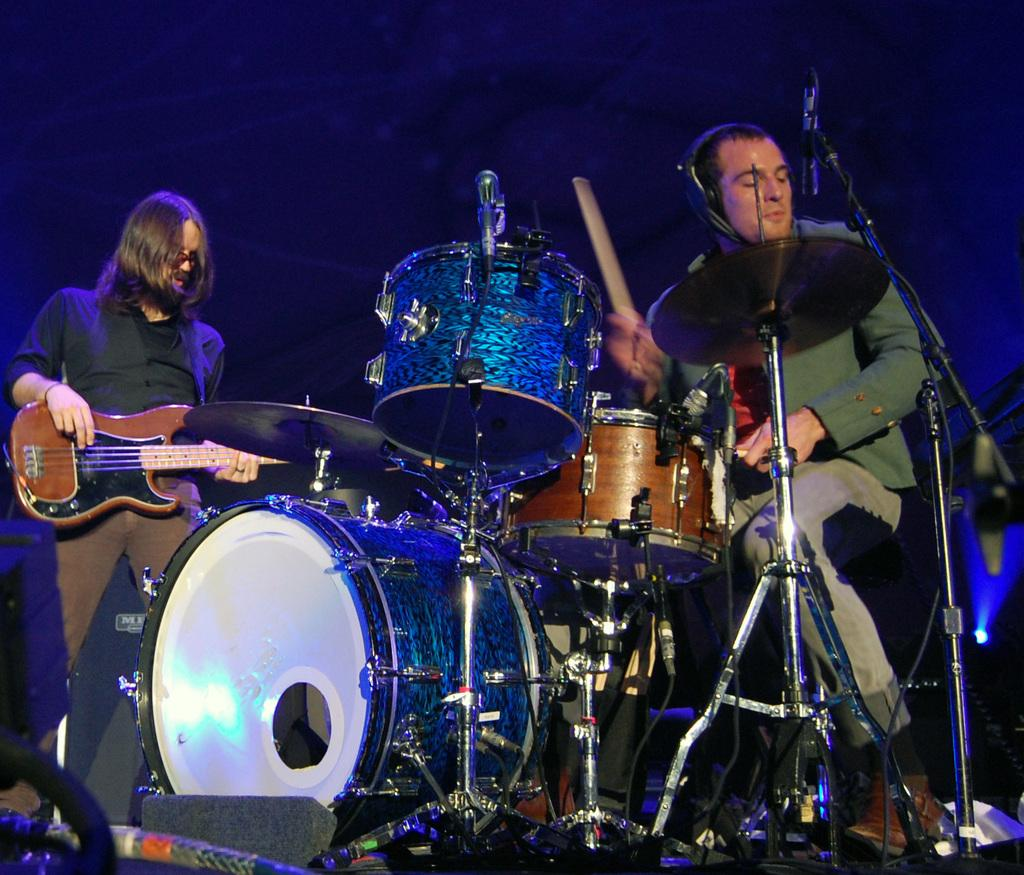What is the man on the left side of the image doing? The man on the left side of the image is playing the guitar. What is the man on the right side of the image doing? The man on the right side of the image is sitting in a chair and beating the drums. How many people are in the image? There are two people in the image. How many kittens are playing with a brick in the image? There are no kittens or bricks present in the image. 